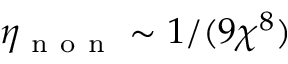<formula> <loc_0><loc_0><loc_500><loc_500>\eta _ { n o n } \sim 1 / ( 9 \chi ^ { 8 } )</formula> 